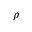<formula> <loc_0><loc_0><loc_500><loc_500>\rho</formula> 